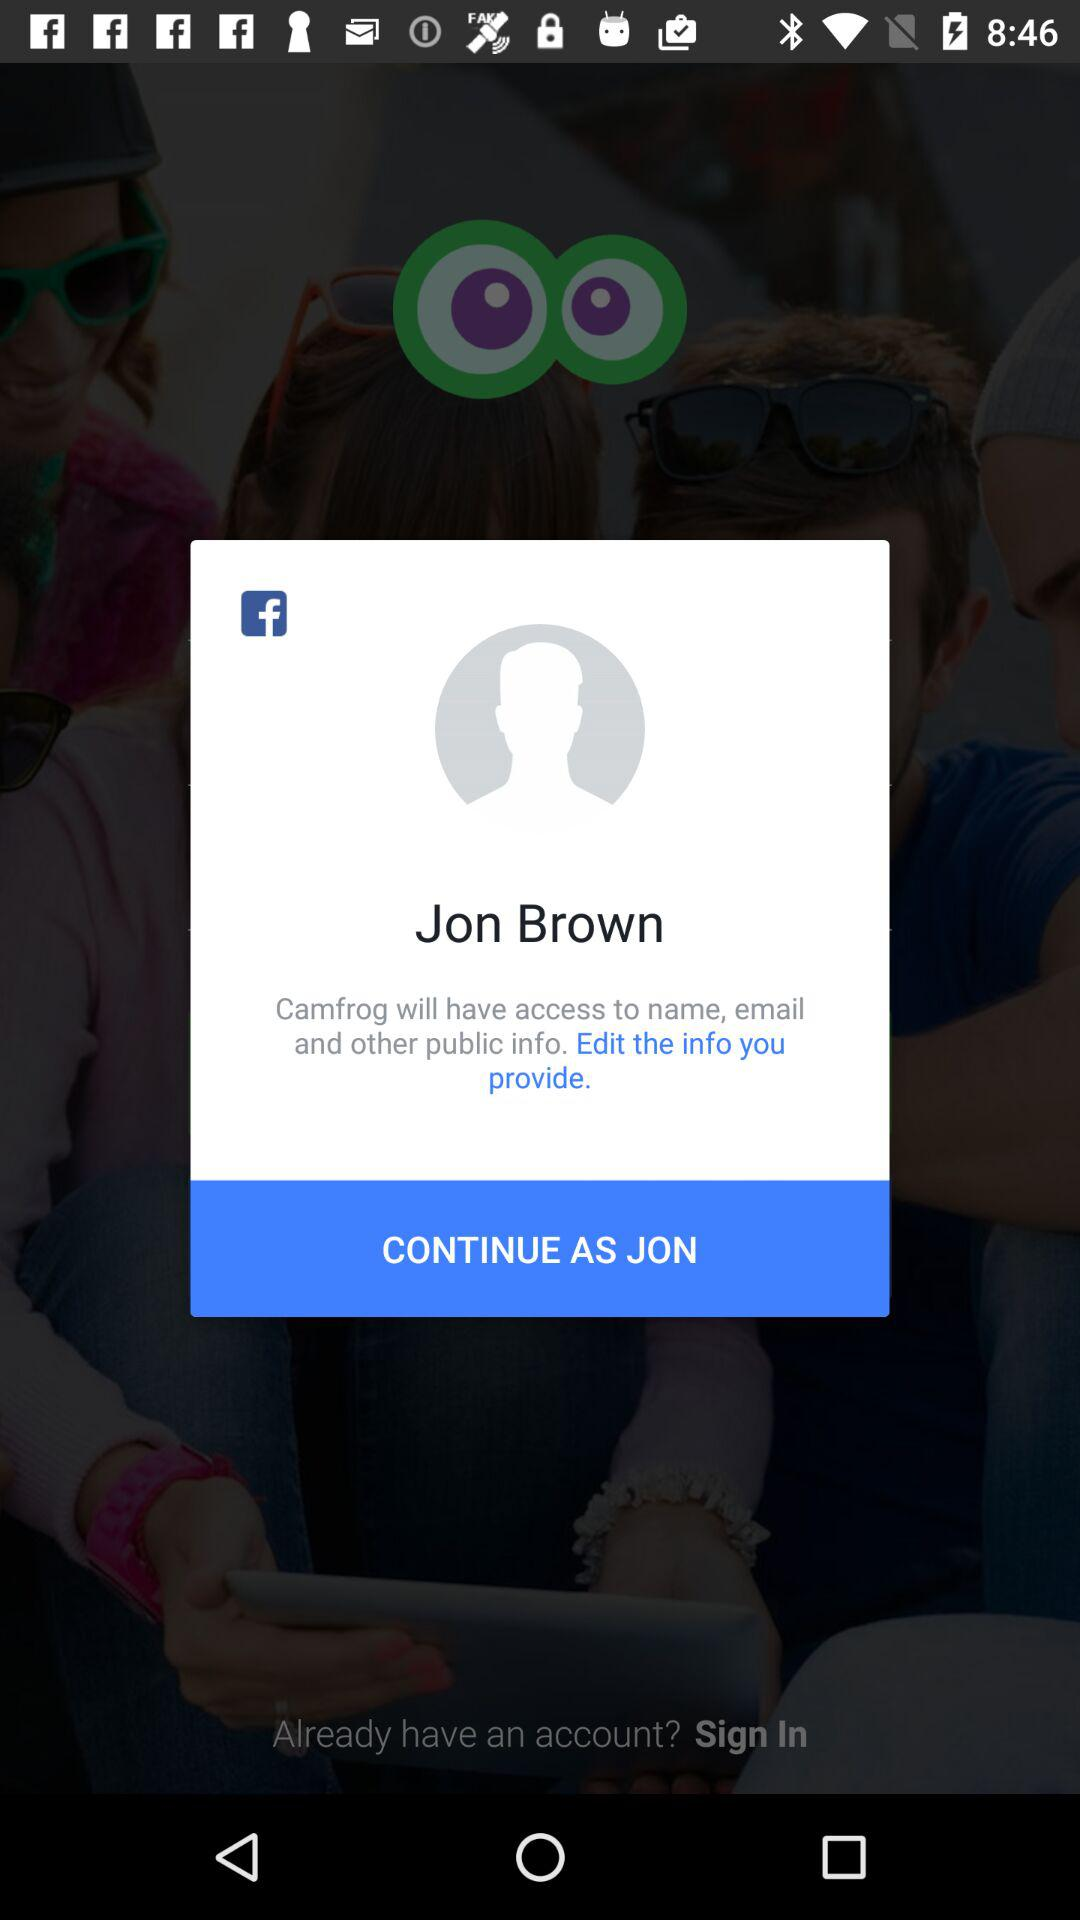Which email address will "Camfrog" have access to?
When the provided information is insufficient, respond with <no answer>. <no answer> 